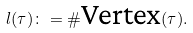Convert formula to latex. <formula><loc_0><loc_0><loc_500><loc_500>l ( \tau ) \colon = \# \text {Vertex} ( \tau ) .</formula> 